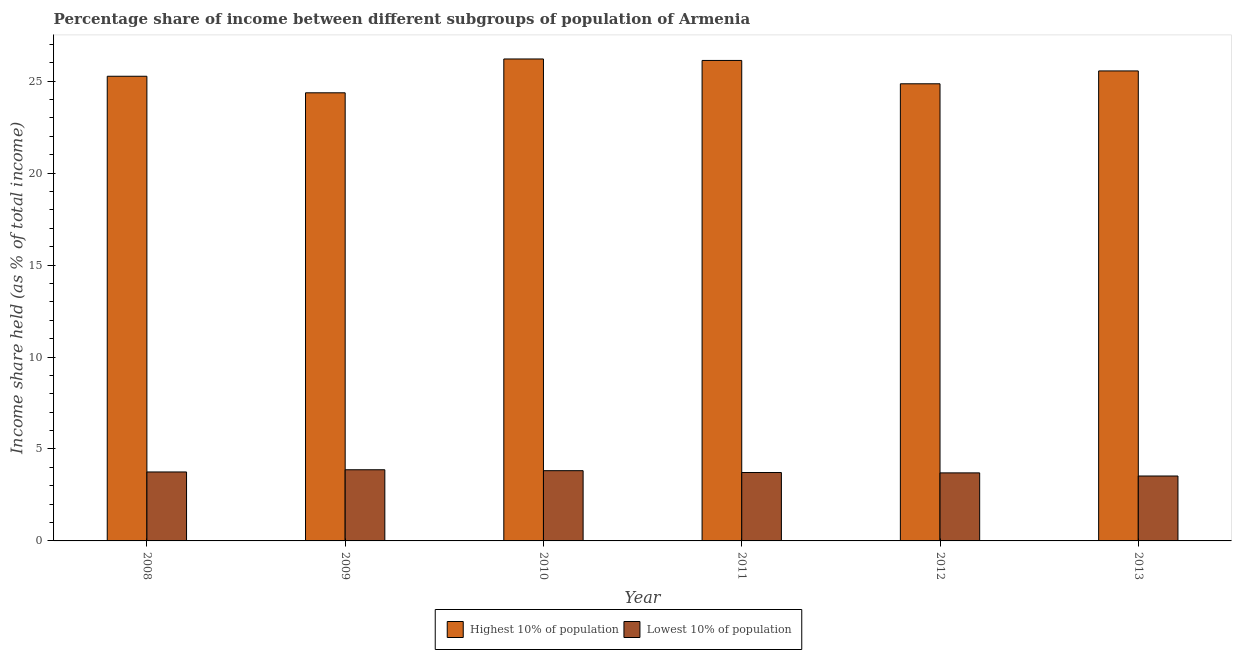Are the number of bars per tick equal to the number of legend labels?
Make the answer very short. Yes. Are the number of bars on each tick of the X-axis equal?
Keep it short and to the point. Yes. How many bars are there on the 5th tick from the right?
Your answer should be compact. 2. In how many cases, is the number of bars for a given year not equal to the number of legend labels?
Keep it short and to the point. 0. What is the income share held by lowest 10% of the population in 2011?
Keep it short and to the point. 3.72. Across all years, what is the maximum income share held by highest 10% of the population?
Ensure brevity in your answer.  26.21. Across all years, what is the minimum income share held by highest 10% of the population?
Provide a short and direct response. 24.37. In which year was the income share held by highest 10% of the population maximum?
Offer a terse response. 2010. In which year was the income share held by highest 10% of the population minimum?
Offer a terse response. 2009. What is the total income share held by lowest 10% of the population in the graph?
Keep it short and to the point. 22.39. What is the difference between the income share held by highest 10% of the population in 2009 and that in 2011?
Give a very brief answer. -1.76. What is the difference between the income share held by lowest 10% of the population in 2008 and the income share held by highest 10% of the population in 2010?
Ensure brevity in your answer.  -0.07. What is the average income share held by lowest 10% of the population per year?
Your answer should be very brief. 3.73. In how many years, is the income share held by highest 10% of the population greater than 5 %?
Make the answer very short. 6. What is the ratio of the income share held by lowest 10% of the population in 2011 to that in 2012?
Give a very brief answer. 1.01. What is the difference between the highest and the second highest income share held by lowest 10% of the population?
Keep it short and to the point. 0.05. What is the difference between the highest and the lowest income share held by lowest 10% of the population?
Your response must be concise. 0.34. Is the sum of the income share held by highest 10% of the population in 2009 and 2010 greater than the maximum income share held by lowest 10% of the population across all years?
Your response must be concise. Yes. What does the 1st bar from the left in 2013 represents?
Your answer should be very brief. Highest 10% of population. What does the 2nd bar from the right in 2012 represents?
Offer a very short reply. Highest 10% of population. What is the difference between two consecutive major ticks on the Y-axis?
Offer a very short reply. 5. Are the values on the major ticks of Y-axis written in scientific E-notation?
Provide a short and direct response. No. How are the legend labels stacked?
Provide a succinct answer. Horizontal. What is the title of the graph?
Your answer should be compact. Percentage share of income between different subgroups of population of Armenia. Does "Primary education" appear as one of the legend labels in the graph?
Make the answer very short. No. What is the label or title of the X-axis?
Offer a terse response. Year. What is the label or title of the Y-axis?
Make the answer very short. Income share held (as % of total income). What is the Income share held (as % of total income) in Highest 10% of population in 2008?
Offer a very short reply. 25.27. What is the Income share held (as % of total income) of Lowest 10% of population in 2008?
Your answer should be very brief. 3.75. What is the Income share held (as % of total income) of Highest 10% of population in 2009?
Give a very brief answer. 24.37. What is the Income share held (as % of total income) in Lowest 10% of population in 2009?
Provide a short and direct response. 3.87. What is the Income share held (as % of total income) of Highest 10% of population in 2010?
Keep it short and to the point. 26.21. What is the Income share held (as % of total income) of Lowest 10% of population in 2010?
Offer a terse response. 3.82. What is the Income share held (as % of total income) in Highest 10% of population in 2011?
Provide a succinct answer. 26.13. What is the Income share held (as % of total income) in Lowest 10% of population in 2011?
Your answer should be very brief. 3.72. What is the Income share held (as % of total income) in Highest 10% of population in 2012?
Provide a succinct answer. 24.86. What is the Income share held (as % of total income) of Lowest 10% of population in 2012?
Ensure brevity in your answer.  3.7. What is the Income share held (as % of total income) in Highest 10% of population in 2013?
Your response must be concise. 25.56. What is the Income share held (as % of total income) in Lowest 10% of population in 2013?
Offer a terse response. 3.53. Across all years, what is the maximum Income share held (as % of total income) of Highest 10% of population?
Make the answer very short. 26.21. Across all years, what is the maximum Income share held (as % of total income) in Lowest 10% of population?
Make the answer very short. 3.87. Across all years, what is the minimum Income share held (as % of total income) in Highest 10% of population?
Provide a succinct answer. 24.37. Across all years, what is the minimum Income share held (as % of total income) in Lowest 10% of population?
Your answer should be very brief. 3.53. What is the total Income share held (as % of total income) of Highest 10% of population in the graph?
Keep it short and to the point. 152.4. What is the total Income share held (as % of total income) of Lowest 10% of population in the graph?
Your answer should be very brief. 22.39. What is the difference between the Income share held (as % of total income) in Lowest 10% of population in 2008 and that in 2009?
Make the answer very short. -0.12. What is the difference between the Income share held (as % of total income) of Highest 10% of population in 2008 and that in 2010?
Ensure brevity in your answer.  -0.94. What is the difference between the Income share held (as % of total income) of Lowest 10% of population in 2008 and that in 2010?
Provide a short and direct response. -0.07. What is the difference between the Income share held (as % of total income) in Highest 10% of population in 2008 and that in 2011?
Your answer should be very brief. -0.86. What is the difference between the Income share held (as % of total income) in Highest 10% of population in 2008 and that in 2012?
Offer a terse response. 0.41. What is the difference between the Income share held (as % of total income) in Lowest 10% of population in 2008 and that in 2012?
Provide a short and direct response. 0.05. What is the difference between the Income share held (as % of total income) of Highest 10% of population in 2008 and that in 2013?
Offer a very short reply. -0.29. What is the difference between the Income share held (as % of total income) in Lowest 10% of population in 2008 and that in 2013?
Ensure brevity in your answer.  0.22. What is the difference between the Income share held (as % of total income) of Highest 10% of population in 2009 and that in 2010?
Your response must be concise. -1.84. What is the difference between the Income share held (as % of total income) in Highest 10% of population in 2009 and that in 2011?
Your answer should be very brief. -1.76. What is the difference between the Income share held (as % of total income) of Lowest 10% of population in 2009 and that in 2011?
Ensure brevity in your answer.  0.15. What is the difference between the Income share held (as % of total income) of Highest 10% of population in 2009 and that in 2012?
Your answer should be compact. -0.49. What is the difference between the Income share held (as % of total income) in Lowest 10% of population in 2009 and that in 2012?
Give a very brief answer. 0.17. What is the difference between the Income share held (as % of total income) of Highest 10% of population in 2009 and that in 2013?
Make the answer very short. -1.19. What is the difference between the Income share held (as % of total income) of Lowest 10% of population in 2009 and that in 2013?
Your answer should be very brief. 0.34. What is the difference between the Income share held (as % of total income) in Highest 10% of population in 2010 and that in 2012?
Provide a succinct answer. 1.35. What is the difference between the Income share held (as % of total income) in Lowest 10% of population in 2010 and that in 2012?
Offer a terse response. 0.12. What is the difference between the Income share held (as % of total income) in Highest 10% of population in 2010 and that in 2013?
Make the answer very short. 0.65. What is the difference between the Income share held (as % of total income) of Lowest 10% of population in 2010 and that in 2013?
Give a very brief answer. 0.29. What is the difference between the Income share held (as % of total income) in Highest 10% of population in 2011 and that in 2012?
Your response must be concise. 1.27. What is the difference between the Income share held (as % of total income) in Highest 10% of population in 2011 and that in 2013?
Give a very brief answer. 0.57. What is the difference between the Income share held (as % of total income) of Lowest 10% of population in 2011 and that in 2013?
Offer a terse response. 0.19. What is the difference between the Income share held (as % of total income) in Highest 10% of population in 2012 and that in 2013?
Offer a very short reply. -0.7. What is the difference between the Income share held (as % of total income) in Lowest 10% of population in 2012 and that in 2013?
Your response must be concise. 0.17. What is the difference between the Income share held (as % of total income) of Highest 10% of population in 2008 and the Income share held (as % of total income) of Lowest 10% of population in 2009?
Your answer should be very brief. 21.4. What is the difference between the Income share held (as % of total income) in Highest 10% of population in 2008 and the Income share held (as % of total income) in Lowest 10% of population in 2010?
Give a very brief answer. 21.45. What is the difference between the Income share held (as % of total income) of Highest 10% of population in 2008 and the Income share held (as % of total income) of Lowest 10% of population in 2011?
Your response must be concise. 21.55. What is the difference between the Income share held (as % of total income) in Highest 10% of population in 2008 and the Income share held (as % of total income) in Lowest 10% of population in 2012?
Offer a very short reply. 21.57. What is the difference between the Income share held (as % of total income) in Highest 10% of population in 2008 and the Income share held (as % of total income) in Lowest 10% of population in 2013?
Offer a terse response. 21.74. What is the difference between the Income share held (as % of total income) of Highest 10% of population in 2009 and the Income share held (as % of total income) of Lowest 10% of population in 2010?
Ensure brevity in your answer.  20.55. What is the difference between the Income share held (as % of total income) in Highest 10% of population in 2009 and the Income share held (as % of total income) in Lowest 10% of population in 2011?
Provide a short and direct response. 20.65. What is the difference between the Income share held (as % of total income) in Highest 10% of population in 2009 and the Income share held (as % of total income) in Lowest 10% of population in 2012?
Provide a short and direct response. 20.67. What is the difference between the Income share held (as % of total income) of Highest 10% of population in 2009 and the Income share held (as % of total income) of Lowest 10% of population in 2013?
Give a very brief answer. 20.84. What is the difference between the Income share held (as % of total income) in Highest 10% of population in 2010 and the Income share held (as % of total income) in Lowest 10% of population in 2011?
Give a very brief answer. 22.49. What is the difference between the Income share held (as % of total income) in Highest 10% of population in 2010 and the Income share held (as % of total income) in Lowest 10% of population in 2012?
Offer a terse response. 22.51. What is the difference between the Income share held (as % of total income) of Highest 10% of population in 2010 and the Income share held (as % of total income) of Lowest 10% of population in 2013?
Ensure brevity in your answer.  22.68. What is the difference between the Income share held (as % of total income) of Highest 10% of population in 2011 and the Income share held (as % of total income) of Lowest 10% of population in 2012?
Your answer should be compact. 22.43. What is the difference between the Income share held (as % of total income) of Highest 10% of population in 2011 and the Income share held (as % of total income) of Lowest 10% of population in 2013?
Make the answer very short. 22.6. What is the difference between the Income share held (as % of total income) of Highest 10% of population in 2012 and the Income share held (as % of total income) of Lowest 10% of population in 2013?
Offer a terse response. 21.33. What is the average Income share held (as % of total income) of Highest 10% of population per year?
Make the answer very short. 25.4. What is the average Income share held (as % of total income) of Lowest 10% of population per year?
Your answer should be compact. 3.73. In the year 2008, what is the difference between the Income share held (as % of total income) of Highest 10% of population and Income share held (as % of total income) of Lowest 10% of population?
Provide a short and direct response. 21.52. In the year 2009, what is the difference between the Income share held (as % of total income) in Highest 10% of population and Income share held (as % of total income) in Lowest 10% of population?
Keep it short and to the point. 20.5. In the year 2010, what is the difference between the Income share held (as % of total income) of Highest 10% of population and Income share held (as % of total income) of Lowest 10% of population?
Provide a short and direct response. 22.39. In the year 2011, what is the difference between the Income share held (as % of total income) in Highest 10% of population and Income share held (as % of total income) in Lowest 10% of population?
Ensure brevity in your answer.  22.41. In the year 2012, what is the difference between the Income share held (as % of total income) of Highest 10% of population and Income share held (as % of total income) of Lowest 10% of population?
Give a very brief answer. 21.16. In the year 2013, what is the difference between the Income share held (as % of total income) in Highest 10% of population and Income share held (as % of total income) in Lowest 10% of population?
Your response must be concise. 22.03. What is the ratio of the Income share held (as % of total income) in Highest 10% of population in 2008 to that in 2009?
Make the answer very short. 1.04. What is the ratio of the Income share held (as % of total income) of Highest 10% of population in 2008 to that in 2010?
Provide a short and direct response. 0.96. What is the ratio of the Income share held (as % of total income) in Lowest 10% of population in 2008 to that in 2010?
Your answer should be compact. 0.98. What is the ratio of the Income share held (as % of total income) in Highest 10% of population in 2008 to that in 2011?
Provide a short and direct response. 0.97. What is the ratio of the Income share held (as % of total income) in Highest 10% of population in 2008 to that in 2012?
Offer a very short reply. 1.02. What is the ratio of the Income share held (as % of total income) in Lowest 10% of population in 2008 to that in 2012?
Your answer should be very brief. 1.01. What is the ratio of the Income share held (as % of total income) of Highest 10% of population in 2008 to that in 2013?
Your response must be concise. 0.99. What is the ratio of the Income share held (as % of total income) in Lowest 10% of population in 2008 to that in 2013?
Your answer should be compact. 1.06. What is the ratio of the Income share held (as % of total income) of Highest 10% of population in 2009 to that in 2010?
Give a very brief answer. 0.93. What is the ratio of the Income share held (as % of total income) in Lowest 10% of population in 2009 to that in 2010?
Keep it short and to the point. 1.01. What is the ratio of the Income share held (as % of total income) in Highest 10% of population in 2009 to that in 2011?
Offer a very short reply. 0.93. What is the ratio of the Income share held (as % of total income) of Lowest 10% of population in 2009 to that in 2011?
Provide a succinct answer. 1.04. What is the ratio of the Income share held (as % of total income) in Highest 10% of population in 2009 to that in 2012?
Your answer should be very brief. 0.98. What is the ratio of the Income share held (as % of total income) in Lowest 10% of population in 2009 to that in 2012?
Provide a succinct answer. 1.05. What is the ratio of the Income share held (as % of total income) of Highest 10% of population in 2009 to that in 2013?
Offer a terse response. 0.95. What is the ratio of the Income share held (as % of total income) in Lowest 10% of population in 2009 to that in 2013?
Offer a very short reply. 1.1. What is the ratio of the Income share held (as % of total income) of Highest 10% of population in 2010 to that in 2011?
Ensure brevity in your answer.  1. What is the ratio of the Income share held (as % of total income) in Lowest 10% of population in 2010 to that in 2011?
Offer a terse response. 1.03. What is the ratio of the Income share held (as % of total income) in Highest 10% of population in 2010 to that in 2012?
Offer a very short reply. 1.05. What is the ratio of the Income share held (as % of total income) of Lowest 10% of population in 2010 to that in 2012?
Give a very brief answer. 1.03. What is the ratio of the Income share held (as % of total income) in Highest 10% of population in 2010 to that in 2013?
Your answer should be very brief. 1.03. What is the ratio of the Income share held (as % of total income) in Lowest 10% of population in 2010 to that in 2013?
Keep it short and to the point. 1.08. What is the ratio of the Income share held (as % of total income) in Highest 10% of population in 2011 to that in 2012?
Provide a succinct answer. 1.05. What is the ratio of the Income share held (as % of total income) in Lowest 10% of population in 2011 to that in 2012?
Ensure brevity in your answer.  1.01. What is the ratio of the Income share held (as % of total income) in Highest 10% of population in 2011 to that in 2013?
Make the answer very short. 1.02. What is the ratio of the Income share held (as % of total income) of Lowest 10% of population in 2011 to that in 2013?
Your response must be concise. 1.05. What is the ratio of the Income share held (as % of total income) of Highest 10% of population in 2012 to that in 2013?
Make the answer very short. 0.97. What is the ratio of the Income share held (as % of total income) in Lowest 10% of population in 2012 to that in 2013?
Make the answer very short. 1.05. What is the difference between the highest and the second highest Income share held (as % of total income) of Highest 10% of population?
Your response must be concise. 0.08. What is the difference between the highest and the lowest Income share held (as % of total income) in Highest 10% of population?
Provide a short and direct response. 1.84. What is the difference between the highest and the lowest Income share held (as % of total income) in Lowest 10% of population?
Offer a terse response. 0.34. 